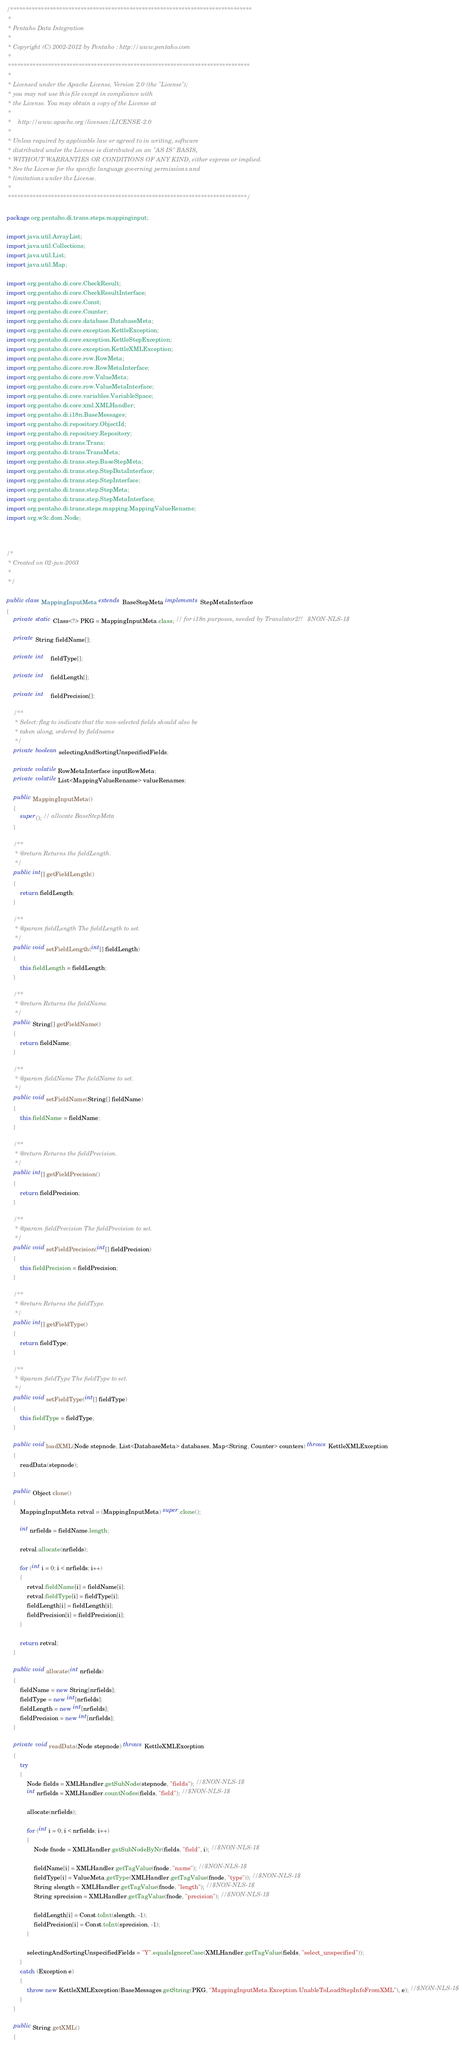<code> <loc_0><loc_0><loc_500><loc_500><_Java_>/*******************************************************************************
 *
 * Pentaho Data Integration
 *
 * Copyright (C) 2002-2012 by Pentaho : http://www.pentaho.com
 *
 *******************************************************************************
 *
 * Licensed under the Apache License, Version 2.0 (the "License");
 * you may not use this file except in compliance with
 * the License. You may obtain a copy of the License at
 *
 *    http://www.apache.org/licenses/LICENSE-2.0
 *
 * Unless required by applicable law or agreed to in writing, software
 * distributed under the License is distributed on an "AS IS" BASIS,
 * WITHOUT WARRANTIES OR CONDITIONS OF ANY KIND, either express or implied.
 * See the License for the specific language governing permissions and
 * limitations under the License.
 *
 ******************************************************************************/

package org.pentaho.di.trans.steps.mappinginput;

import java.util.ArrayList;
import java.util.Collections;
import java.util.List;
import java.util.Map;

import org.pentaho.di.core.CheckResult;
import org.pentaho.di.core.CheckResultInterface;
import org.pentaho.di.core.Const;
import org.pentaho.di.core.Counter;
import org.pentaho.di.core.database.DatabaseMeta;
import org.pentaho.di.core.exception.KettleException;
import org.pentaho.di.core.exception.KettleStepException;
import org.pentaho.di.core.exception.KettleXMLException;
import org.pentaho.di.core.row.RowMeta;
import org.pentaho.di.core.row.RowMetaInterface;
import org.pentaho.di.core.row.ValueMeta;
import org.pentaho.di.core.row.ValueMetaInterface;
import org.pentaho.di.core.variables.VariableSpace;
import org.pentaho.di.core.xml.XMLHandler;
import org.pentaho.di.i18n.BaseMessages;
import org.pentaho.di.repository.ObjectId;
import org.pentaho.di.repository.Repository;
import org.pentaho.di.trans.Trans;
import org.pentaho.di.trans.TransMeta;
import org.pentaho.di.trans.step.BaseStepMeta;
import org.pentaho.di.trans.step.StepDataInterface;
import org.pentaho.di.trans.step.StepInterface;
import org.pentaho.di.trans.step.StepMeta;
import org.pentaho.di.trans.step.StepMetaInterface;
import org.pentaho.di.trans.steps.mapping.MappingValueRename;
import org.w3c.dom.Node;



/*
 * Created on 02-jun-2003
 * 
 */

public class MappingInputMeta extends BaseStepMeta implements StepMetaInterface
{
	private static Class<?> PKG = MappingInputMeta.class; // for i18n purposes, needed by Translator2!!   $NON-NLS-1$

    private String fieldName[];

    private int    fieldType[];

    private int    fieldLength[];

    private int    fieldPrecision[];
    
    /**
	 * Select: flag to indicate that the non-selected fields should also be
	 * taken along, ordered by fieldname
	 */
    private boolean selectingAndSortingUnspecifiedFields;

	private volatile RowMetaInterface inputRowMeta;
	private volatile List<MappingValueRename> valueRenames;

    public MappingInputMeta()
    {
        super(); // allocate BaseStepMeta
    }

    /**
     * @return Returns the fieldLength.
     */
    public int[] getFieldLength()
    {
        return fieldLength;
    }

    /**
     * @param fieldLength The fieldLength to set.
     */
    public void setFieldLength(int[] fieldLength)
    {
        this.fieldLength = fieldLength;
    }

    /**
     * @return Returns the fieldName.
     */
    public String[] getFieldName()
    {
        return fieldName;
    }

    /**
     * @param fieldName The fieldName to set.
     */
    public void setFieldName(String[] fieldName)
    {
        this.fieldName = fieldName;
    }

    /**
     * @return Returns the fieldPrecision.
     */
    public int[] getFieldPrecision()
    {
        return fieldPrecision;
    }

    /**
     * @param fieldPrecision The fieldPrecision to set.
     */
    public void setFieldPrecision(int[] fieldPrecision)
    {
        this.fieldPrecision = fieldPrecision;
    }

    /**
     * @return Returns the fieldType.
     */
    public int[] getFieldType()
    {
        return fieldType;
    }

    /**
     * @param fieldType The fieldType to set.
     */
    public void setFieldType(int[] fieldType)
    {
        this.fieldType = fieldType;
    }
    
    public void loadXML(Node stepnode, List<DatabaseMeta> databases, Map<String, Counter> counters) throws KettleXMLException
    {
        readData(stepnode);
    }

    public Object clone()
    {
        MappingInputMeta retval = (MappingInputMeta) super.clone();

        int nrfields = fieldName.length;

        retval.allocate(nrfields);

        for (int i = 0; i < nrfields; i++)
        {
            retval.fieldName[i] = fieldName[i];
            retval.fieldType[i] = fieldType[i];
            fieldLength[i] = fieldLength[i];
            fieldPrecision[i] = fieldPrecision[i];
        }

        return retval;
    }

    public void allocate(int nrfields)
    {
        fieldName = new String[nrfields];
        fieldType = new int[nrfields];
        fieldLength = new int[nrfields];
        fieldPrecision = new int[nrfields];
    }

    private void readData(Node stepnode) throws KettleXMLException
    {
        try
        {
            Node fields = XMLHandler.getSubNode(stepnode, "fields"); //$NON-NLS-1$
            int nrfields = XMLHandler.countNodes(fields, "field"); //$NON-NLS-1$

            allocate(nrfields);

            for (int i = 0; i < nrfields; i++)
            {
                Node fnode = XMLHandler.getSubNodeByNr(fields, "field", i); //$NON-NLS-1$

                fieldName[i] = XMLHandler.getTagValue(fnode, "name"); //$NON-NLS-1$
                fieldType[i] = ValueMeta.getType(XMLHandler.getTagValue(fnode, "type")); //$NON-NLS-1$
                String slength = XMLHandler.getTagValue(fnode, "length"); //$NON-NLS-1$
                String sprecision = XMLHandler.getTagValue(fnode, "precision"); //$NON-NLS-1$

                fieldLength[i] = Const.toInt(slength, -1);
                fieldPrecision[i] = Const.toInt(sprecision, -1);
            }
            
			selectingAndSortingUnspecifiedFields = "Y".equalsIgnoreCase(XMLHandler.getTagValue(fields, "select_unspecified"));
        }
        catch (Exception e)
        {
            throw new KettleXMLException(BaseMessages.getString(PKG, "MappingInputMeta.Exception.UnableToLoadStepInfoFromXML"), e); //$NON-NLS-1$
        }
    }

    public String getXML()
    {</code> 